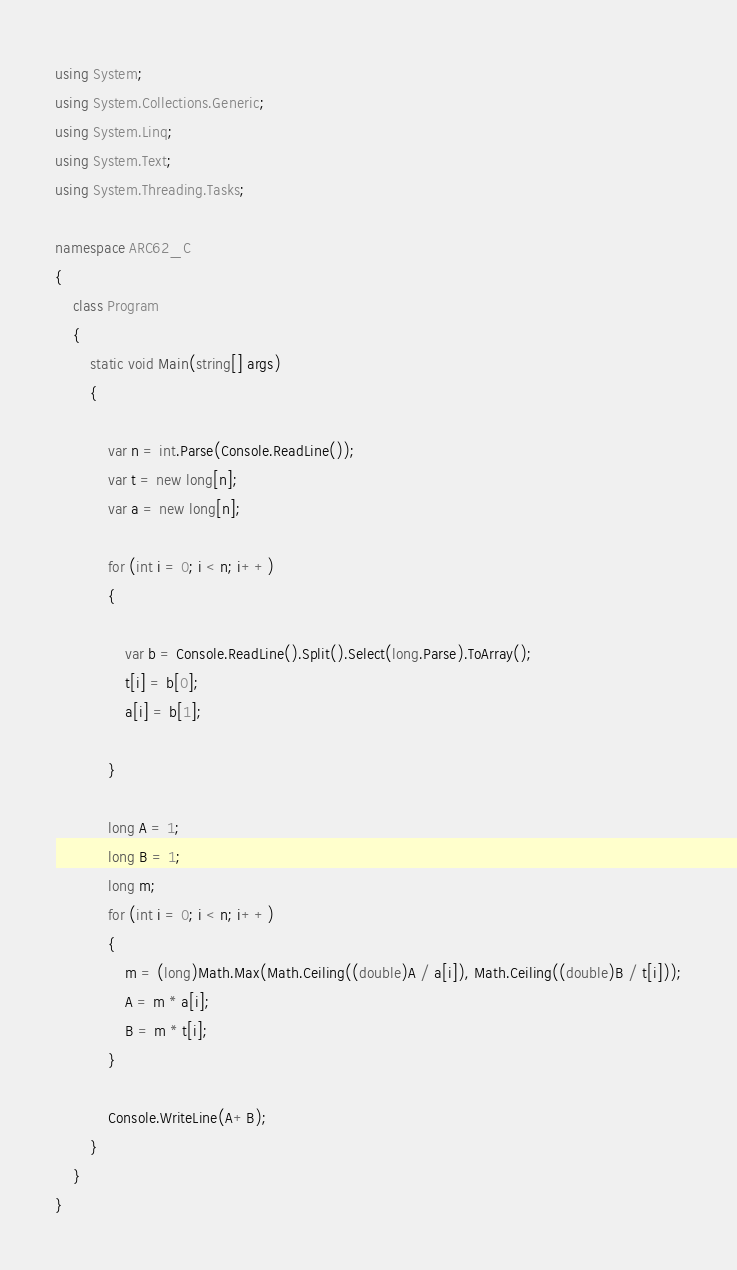<code> <loc_0><loc_0><loc_500><loc_500><_C#_>using System;
using System.Collections.Generic;
using System.Linq;
using System.Text;
using System.Threading.Tasks;

namespace ARC62_C
{
    class Program
    {
        static void Main(string[] args)
        {

            var n = int.Parse(Console.ReadLine());
            var t = new long[n];
            var a = new long[n];

            for (int i = 0; i < n; i++)
            {

                var b = Console.ReadLine().Split().Select(long.Parse).ToArray();
                t[i] = b[0];
                a[i] = b[1];

            }

            long A = 1;
            long B = 1;
            long m;
            for (int i = 0; i < n; i++)
            {
                m = (long)Math.Max(Math.Ceiling((double)A / a[i]), Math.Ceiling((double)B / t[i]));
                A = m * a[i];
                B = m * t[i];
            }

            Console.WriteLine(A+B);
        }
    }
}
</code> 